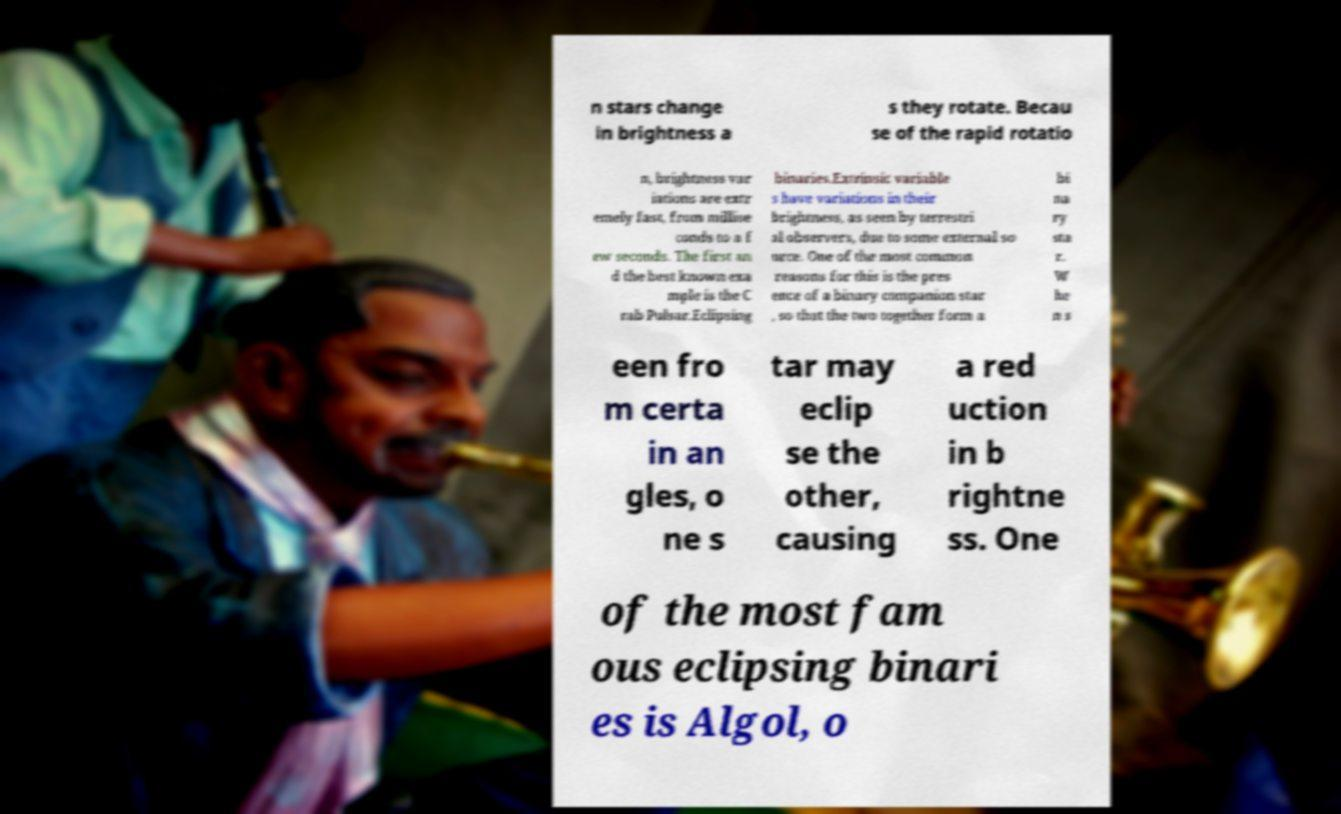I need the written content from this picture converted into text. Can you do that? n stars change in brightness a s they rotate. Becau se of the rapid rotatio n, brightness var iations are extr emely fast, from millise conds to a f ew seconds. The first an d the best known exa mple is the C rab Pulsar.Eclipsing binaries.Extrinsic variable s have variations in their brightness, as seen by terrestri al observers, due to some external so urce. One of the most common reasons for this is the pres ence of a binary companion star , so that the two together form a bi na ry sta r. W he n s een fro m certa in an gles, o ne s tar may eclip se the other, causing a red uction in b rightne ss. One of the most fam ous eclipsing binari es is Algol, o 